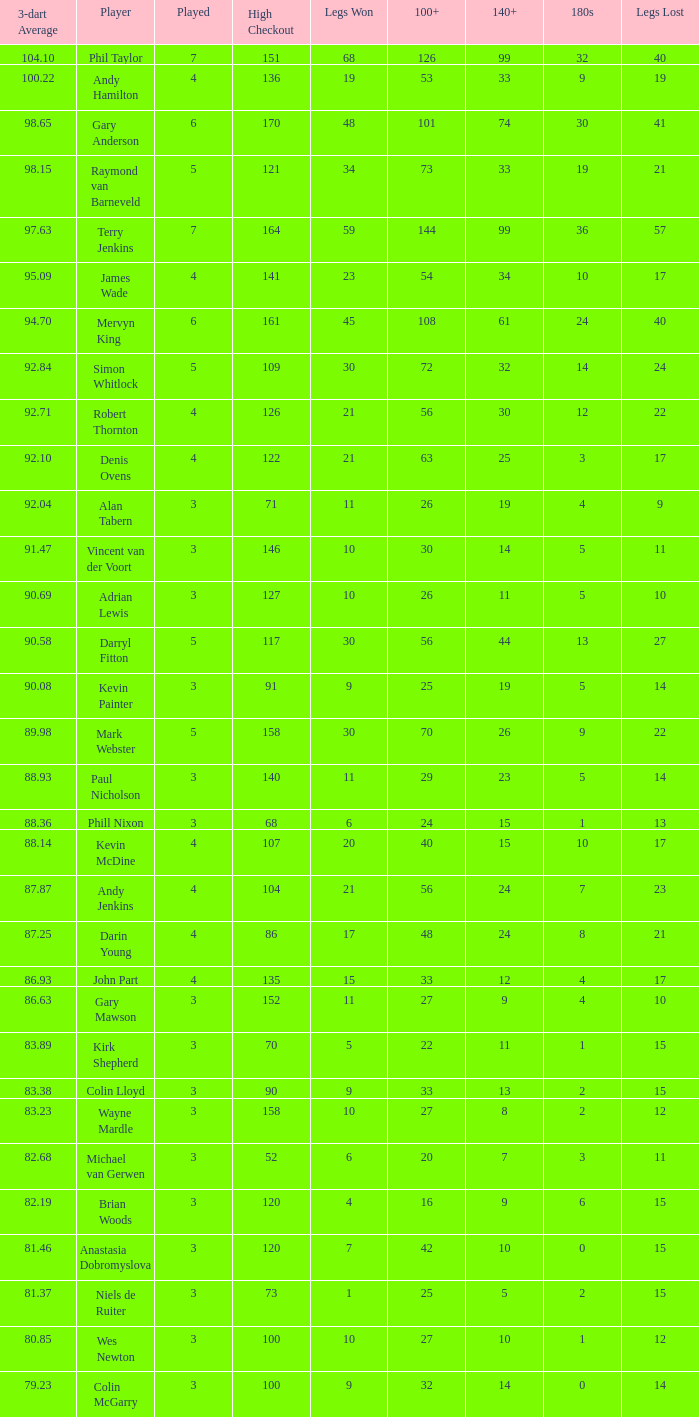What is the total number of 3-dart average when legs lost is larger than 41, and played is larger than 7? 0.0. 